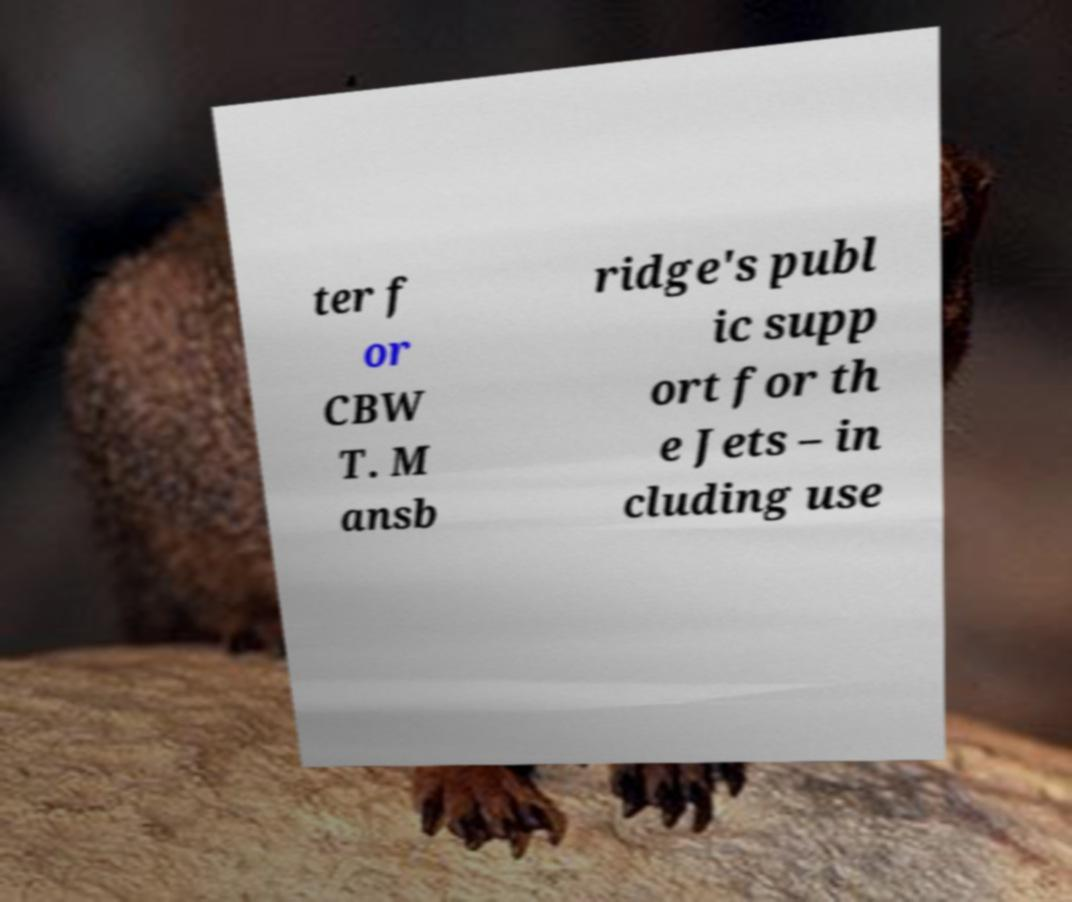Can you accurately transcribe the text from the provided image for me? ter f or CBW T. M ansb ridge's publ ic supp ort for th e Jets – in cluding use 